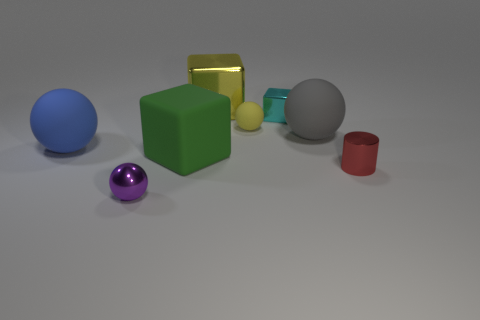How many shiny objects are to the left of the large gray matte thing and behind the metal sphere?
Make the answer very short. 2. What number of shiny things are small red spheres or large green objects?
Provide a short and direct response. 0. The red cylinder to the right of the thing that is in front of the small red metal cylinder is made of what material?
Offer a very short reply. Metal. What is the shape of the metallic thing that is the same color as the small rubber object?
Provide a short and direct response. Cube. What is the shape of the cyan metallic thing that is the same size as the yellow rubber object?
Keep it short and to the point. Cube. Are there fewer matte spheres than balls?
Give a very brief answer. Yes. Is there a yellow rubber object behind the thing that is in front of the cylinder?
Provide a succinct answer. Yes. What is the shape of the large green thing that is made of the same material as the big blue object?
Give a very brief answer. Cube. Are there any other things of the same color as the large shiny object?
Provide a succinct answer. Yes. There is another tiny object that is the same shape as the tiny matte object; what material is it?
Offer a very short reply. Metal. 